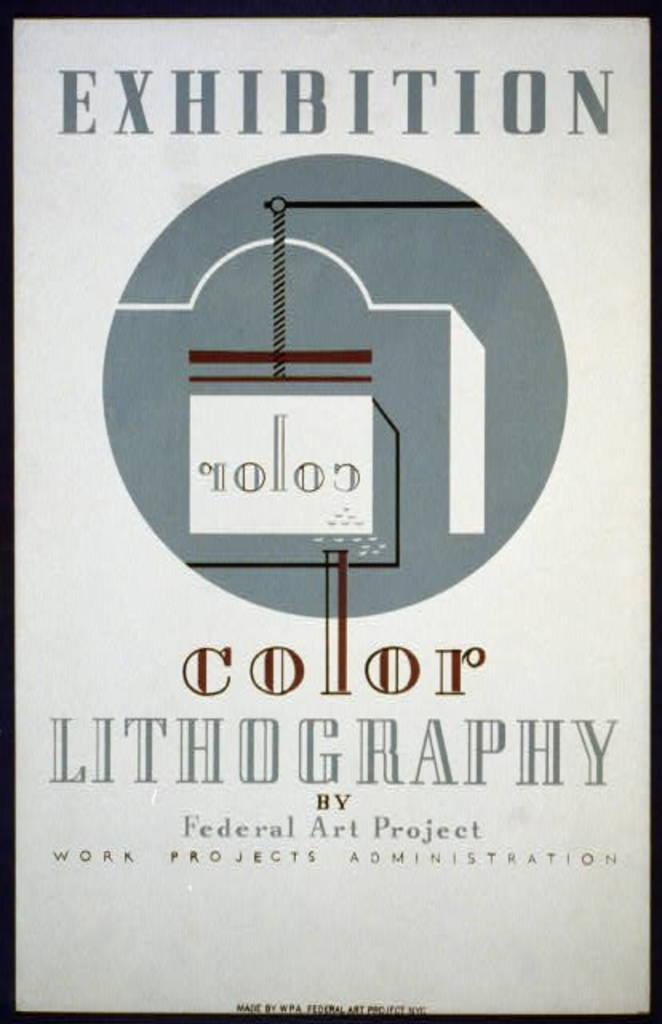<image>
Offer a succinct explanation of the picture presented. A poster with cool toned colors that reads exhibition color lithography upon it. 